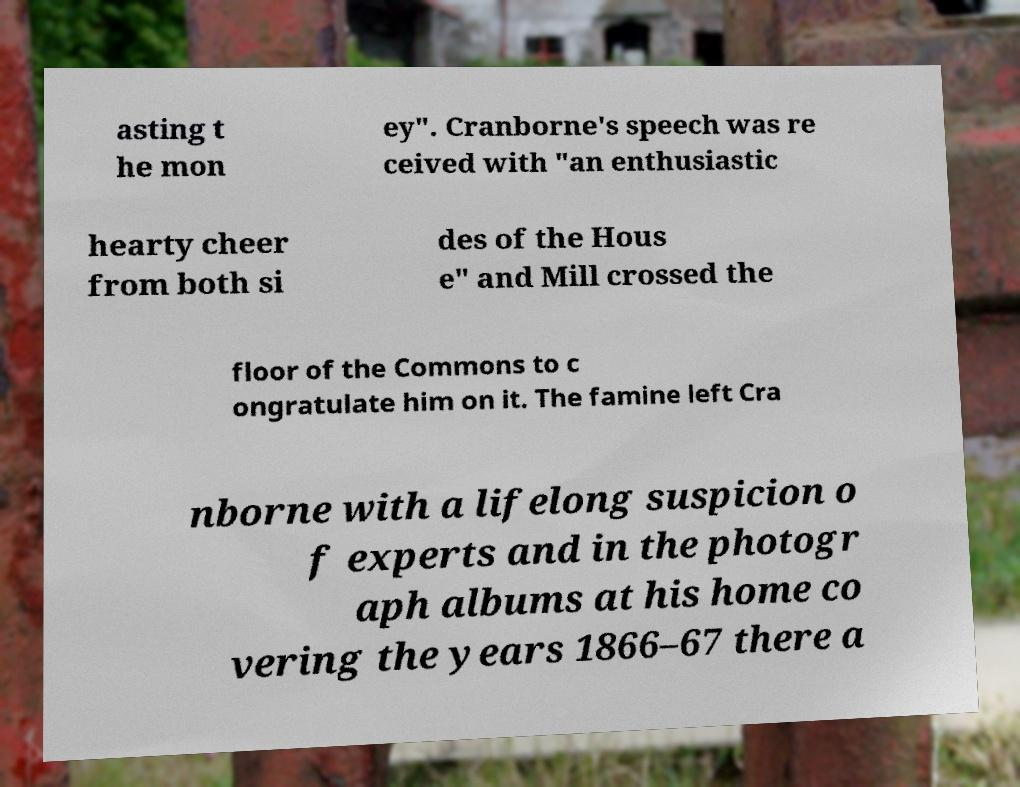What messages or text are displayed in this image? I need them in a readable, typed format. asting t he mon ey". Cranborne's speech was re ceived with "an enthusiastic hearty cheer from both si des of the Hous e" and Mill crossed the floor of the Commons to c ongratulate him on it. The famine left Cra nborne with a lifelong suspicion o f experts and in the photogr aph albums at his home co vering the years 1866–67 there a 